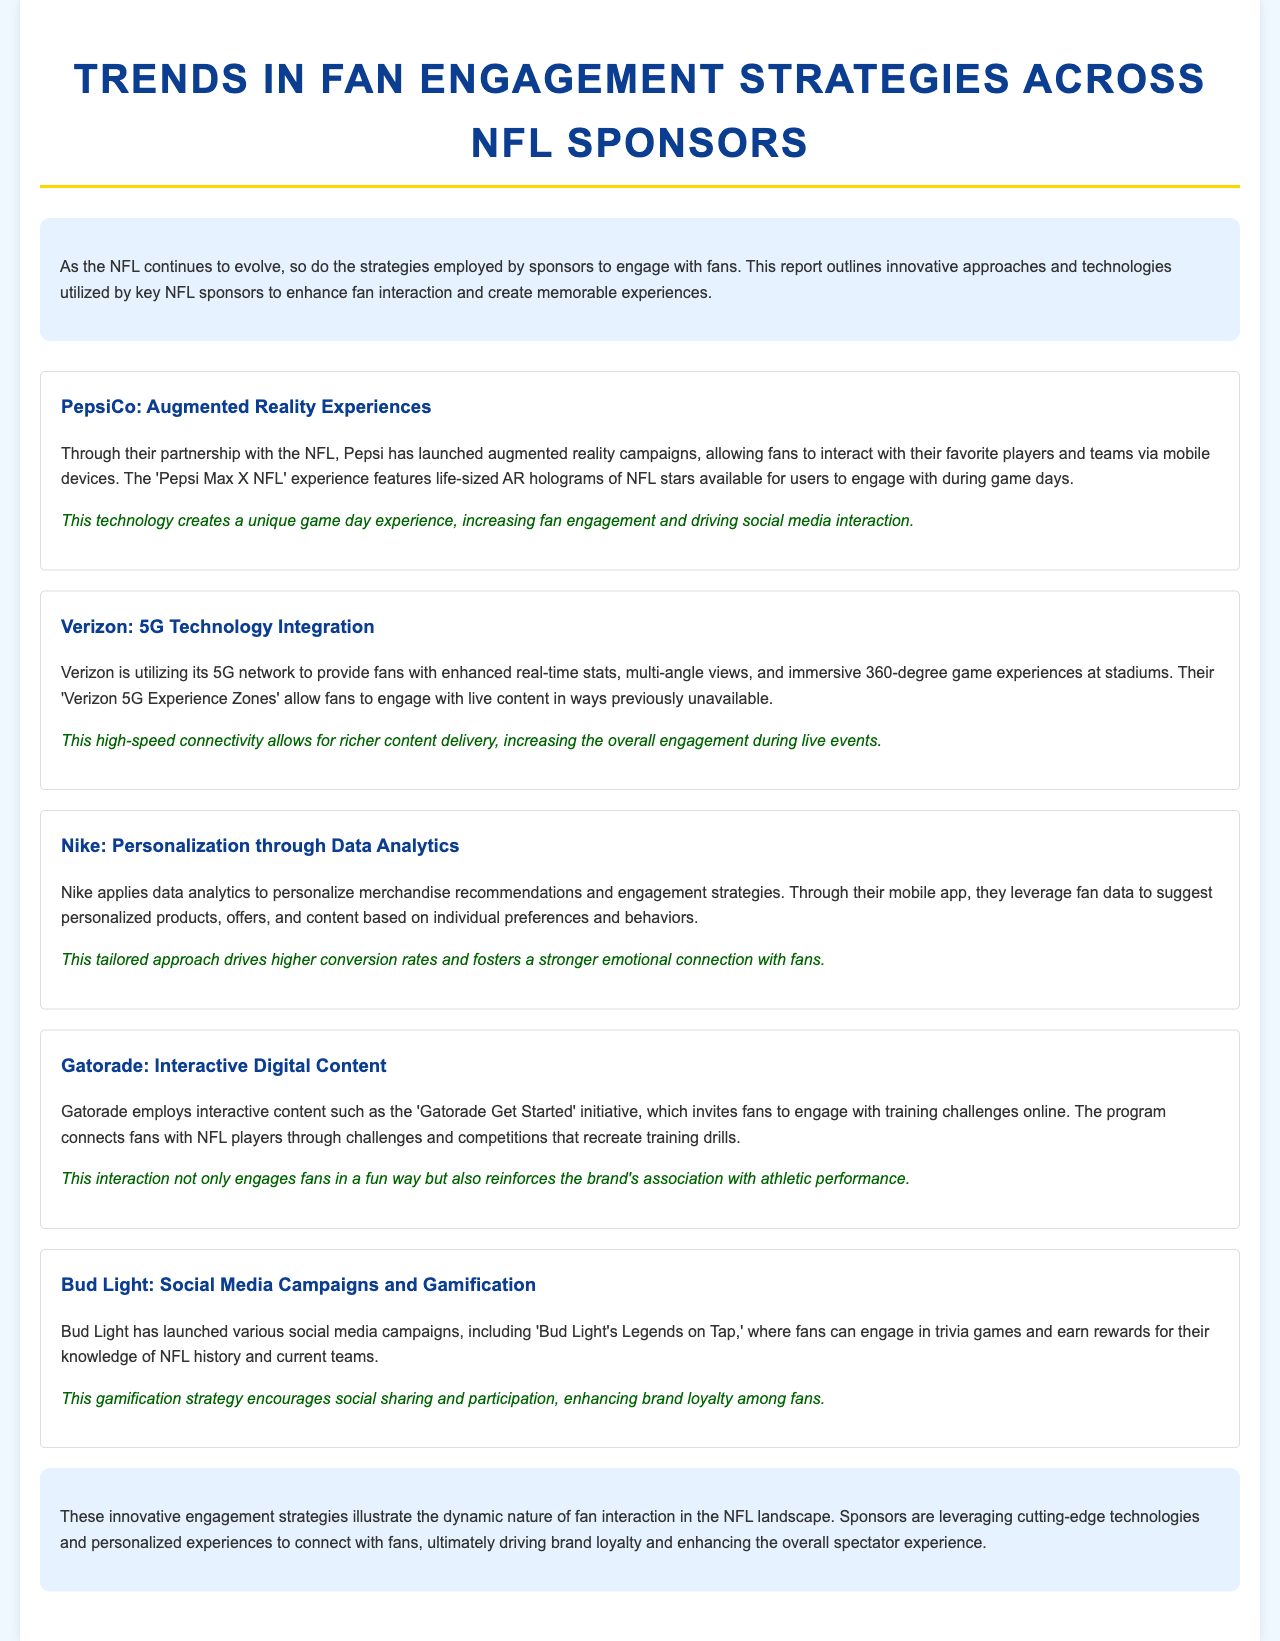What augmented reality experience does PepsiCo offer? PepsiCo offers a 'Pepsi Max X NFL' experience featuring life-sized AR holograms of NFL stars.
Answer: 'Pepsi Max X NFL' What technology is Verizon utilizing to enhance fan engagement? Verizon is utilizing its 5G network to provide enhanced real-time stats and immersive game experiences.
Answer: 5G network What is Nike's approach to personalizing fan engagement? Nike applies data analytics to personalize merchandise recommendations and engagement strategies.
Answer: Data analytics What initiative does Gatorade use to connect fans with NFL players? Gatorade employs the 'Gatorade Get Started' initiative to invite fans to engage with training challenges online.
Answer: 'Gatorade Get Started' What type of campaigns does Bud Light run to engage fans? Bud Light has launched social media campaigns, including 'Bud Light's Legends on Tap' to engage fans in trivia games.
Answer: Social media campaigns How do PepsiCo’s AR experiences affect social media interaction? PepsiCo's AR experiences increase fan engagement and drive social media interaction.
Answer: Increase engagement What is the benefit of Verizon's 5G Experience Zones? Verizon's 5G Experience Zones allow fans to engage with live content in ways previously unavailable.
Answer: Engage with live content What connects Gatorade's interactive content to its brand? Gatorade’s interactive content reinforces the brand's association with athletic performance.
Answer: Athletic performance 